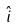Convert formula to latex. <formula><loc_0><loc_0><loc_500><loc_500>\hat { i }</formula> 